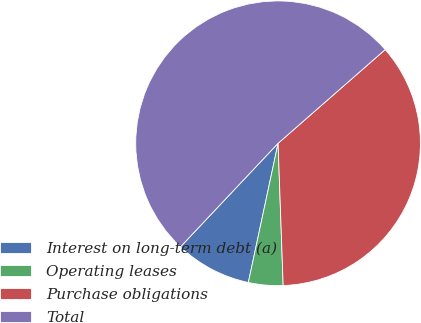Convert chart. <chart><loc_0><loc_0><loc_500><loc_500><pie_chart><fcel>Interest on long-term debt (a)<fcel>Operating leases<fcel>Purchase obligations<fcel>Total<nl><fcel>8.68%<fcel>3.92%<fcel>35.87%<fcel>51.53%<nl></chart> 